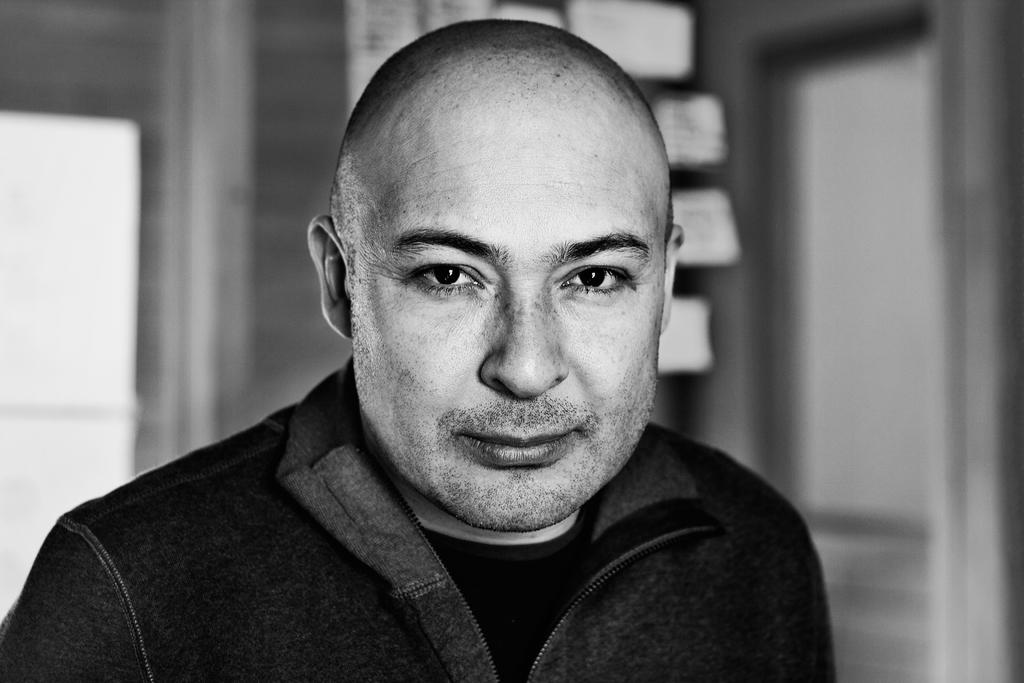What is the color scheme of the image? The image is black and white. Where was the image taken? The image was taken indoors. What can be seen in the background of the image? There is a wall with a window and a door in the background. Who is the main subject in the image? There is a man in the middle of the image. How many oranges are on the table in the image? There are no oranges present in the image. What type of growth can be seen on the man's face in the image? There is no growth visible on the man's face in the image. 